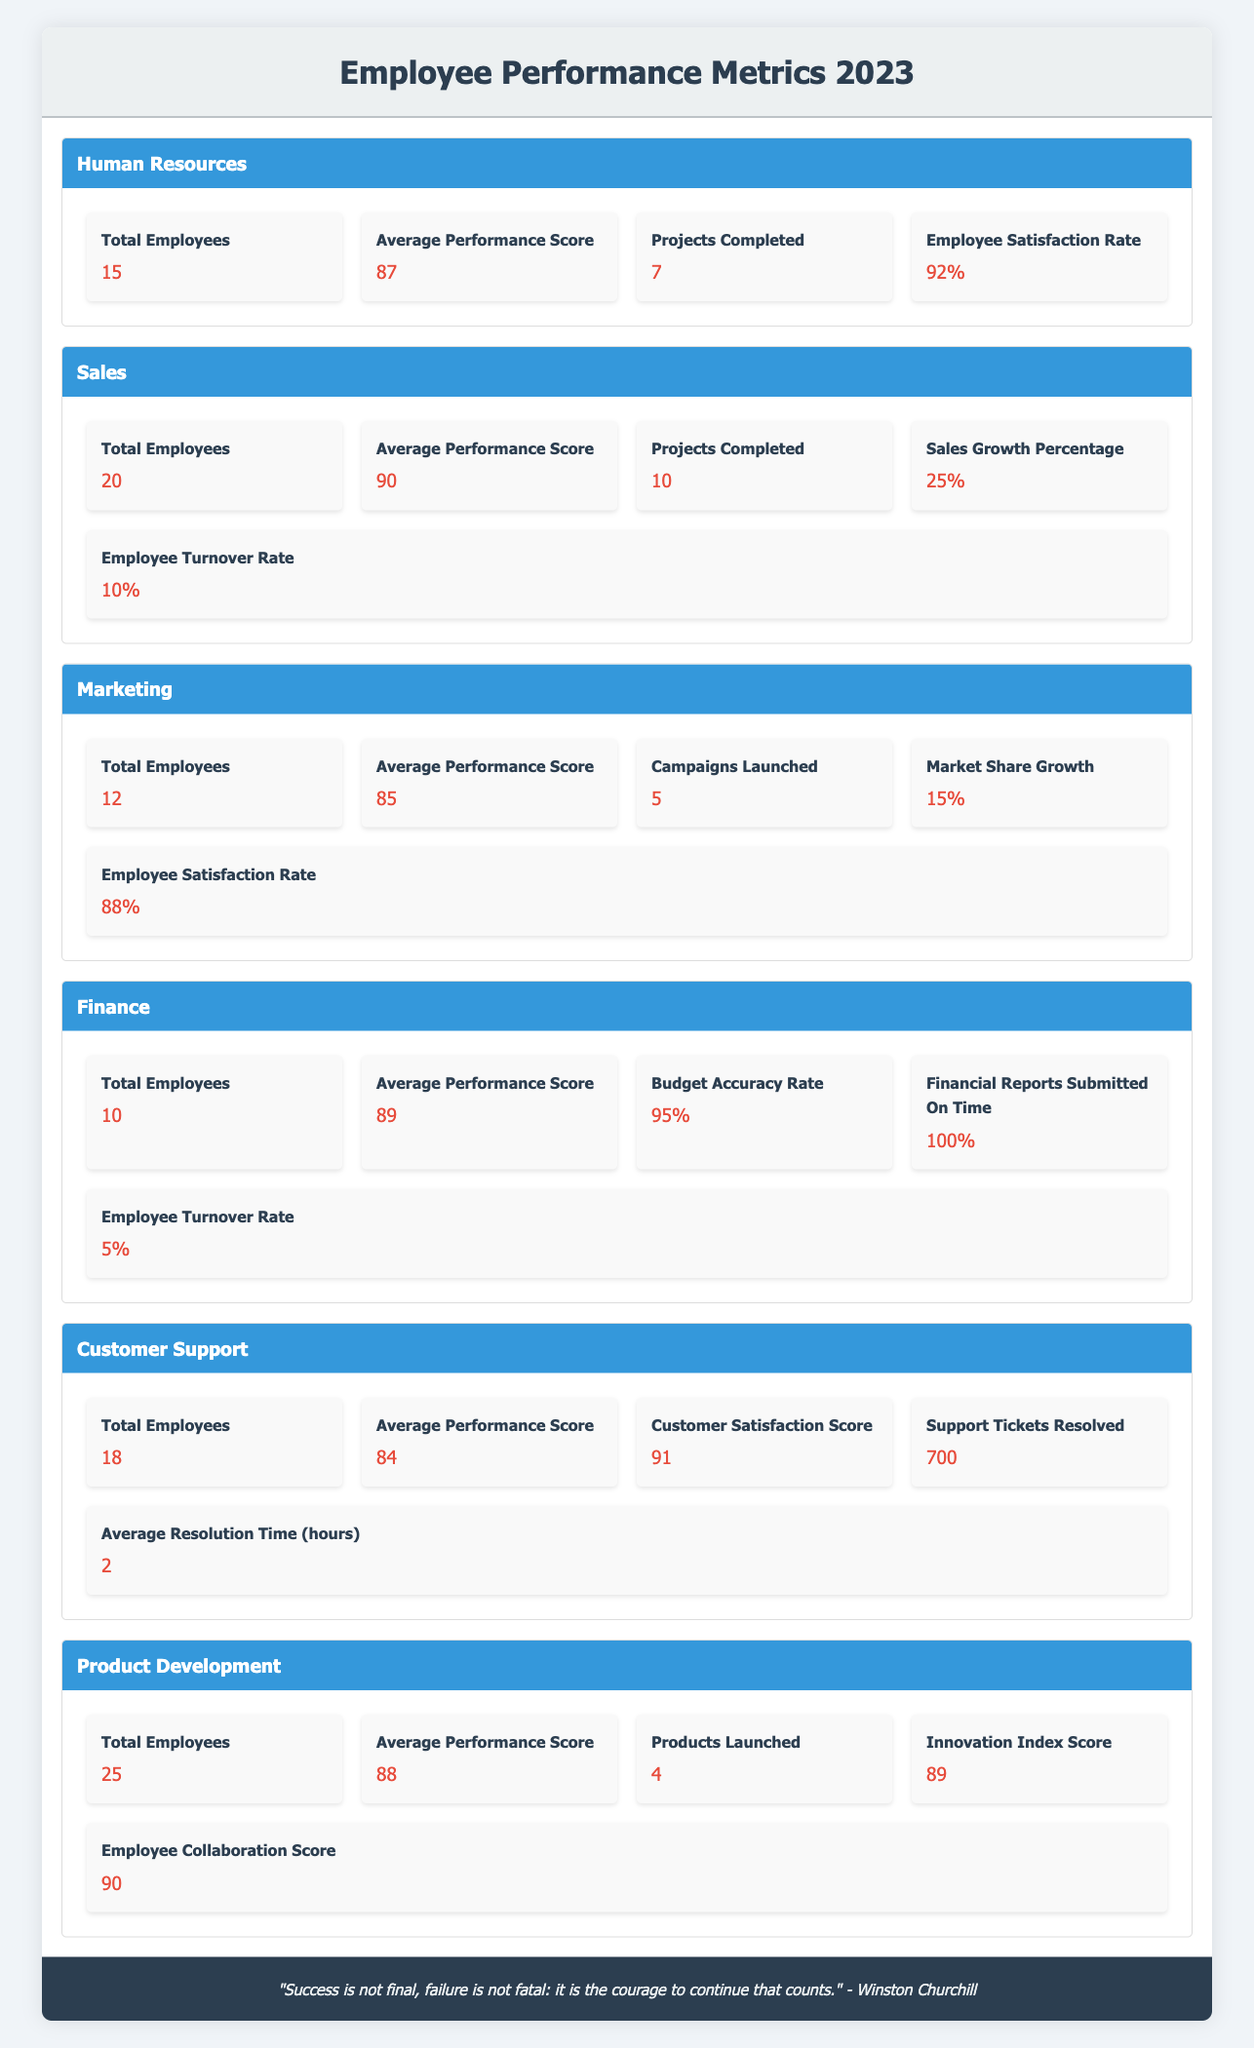What's the total number of employees in the Sales department? The table lists the Sales department with a specified metric of "Total Employees," which shows a value of 20.
Answer: 20 What is the average performance score of the Human Resources department? By looking directly at the individual metrics under the Human Resources department, the "Average Performance Score" is indicated as 87.
Answer: 87 Which department has the highest employee satisfaction rate? The employee satisfaction rates listed for each department are as follows: Human Resources - 92%, Marketing - 88%, Finance - 95%, and Customer Support - 91%. The Finance department has the highest rate at 95%.
Answer: Finance How many projects were completed in total across all departments? The table provides the completed projects for each department: Human Resources - 7, Sales - 10, Marketing - 5, Finance - (not listed), Customer Support - (not listed), Product Development - (not listed). We sum the known values: 7 + 10 + 5 = 22. The total is 22 projects completed, as only Human Resources, Sales, and Marketing have a value listed.
Answer: 22 Is the average performance score of the Customer Support department greater than 85? The table indicates that the average performance score for Customer Support is 84, which is less than 85. Thus, the answer is no.
Answer: No What is the difference between the average performance scores of the Finance and Marketing departments? The average performance score for Finance is 89, and for Marketing, it is 85. The difference is calculated by subtracting these two values: 89 - 85 = 4.
Answer: 4 How many Campaigns were Launched by the Marketing department compared to the Products Launched by the Product Development department? Marketing launched 5 campaigns while Product Development launched 4 products. Comparing these, Marketing launched 1 more campaign than Product Development, so the difference is calculated: 5 - 4 = 1.
Answer: 1 Which department has the lowest employee turnover rate? The turnover rates stated are: Sales - 10%, Finance - 5%, and Customer Support (not listed). Since Finance has the lowest listed rate of 5%, the answer is Finance.
Answer: Finance What is the total average performance score for all departments combined? The average performance scores provided are: Human Resources - 87, Sales - 90, Marketing - 85, Finance - 89, Customer Support - 84, and Product Development - 88. We add all the scores: 87 + 90 + 85 + 89 + 84 + 88 = 513. There are 6 departments, so we calculate the average: 513 / 6 ≈ 85.5.
Answer: 85.5 